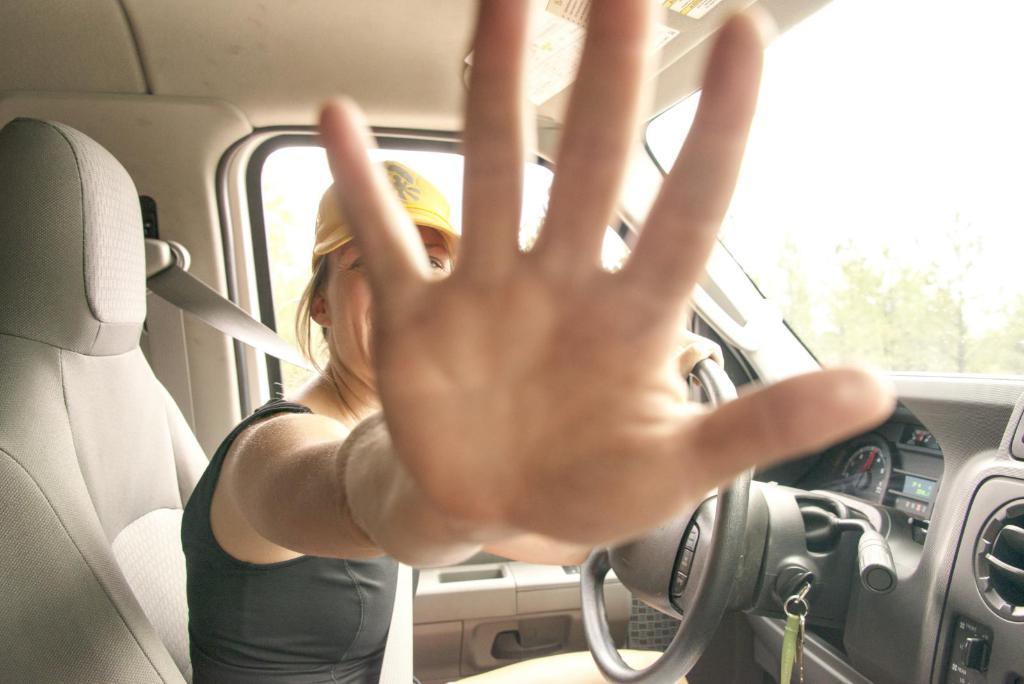Describe this image in one or two sentences. In the center of the image we can see woman sitting in the car. In the background there are trees. 